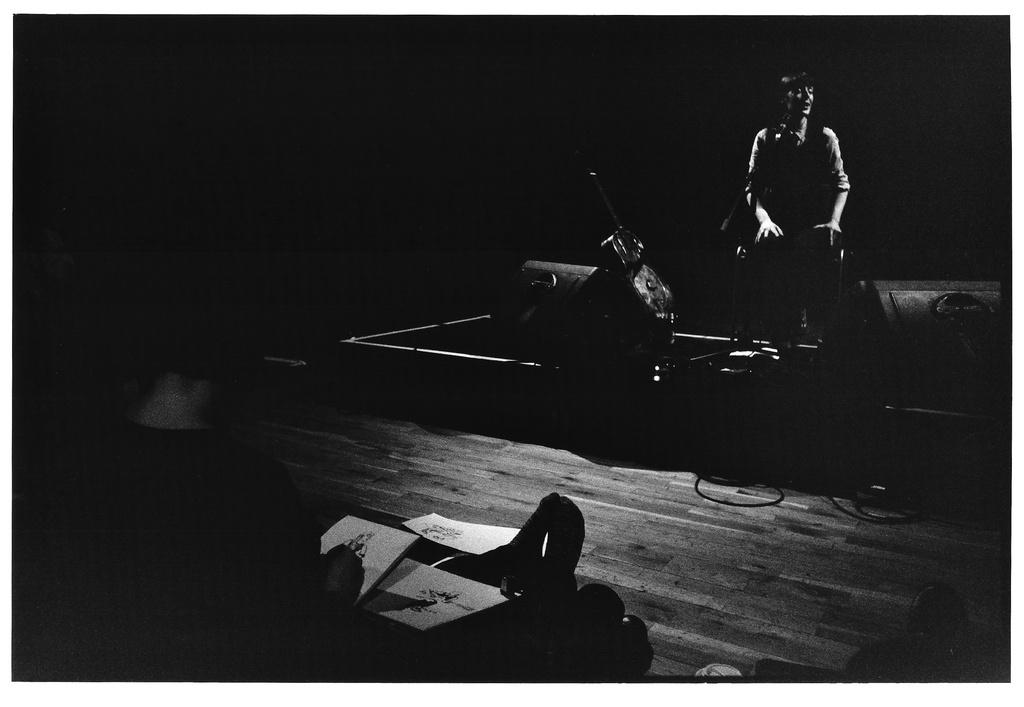What is the color scheme of the image? The image is black and white. Can you describe the actions of the people in the image? There is a person sitting on the right side of the image, and another person is drawing a picture on the left side of the image. What is the subject of the drawing in the image? The person on the left side is drawing a picture of the person on the right side. What type of lettuce is being used as an instrument by the person on the left side of the image? There is no lettuce present in the image, and the person on the left side is drawing a picture, not playing an instrument. 